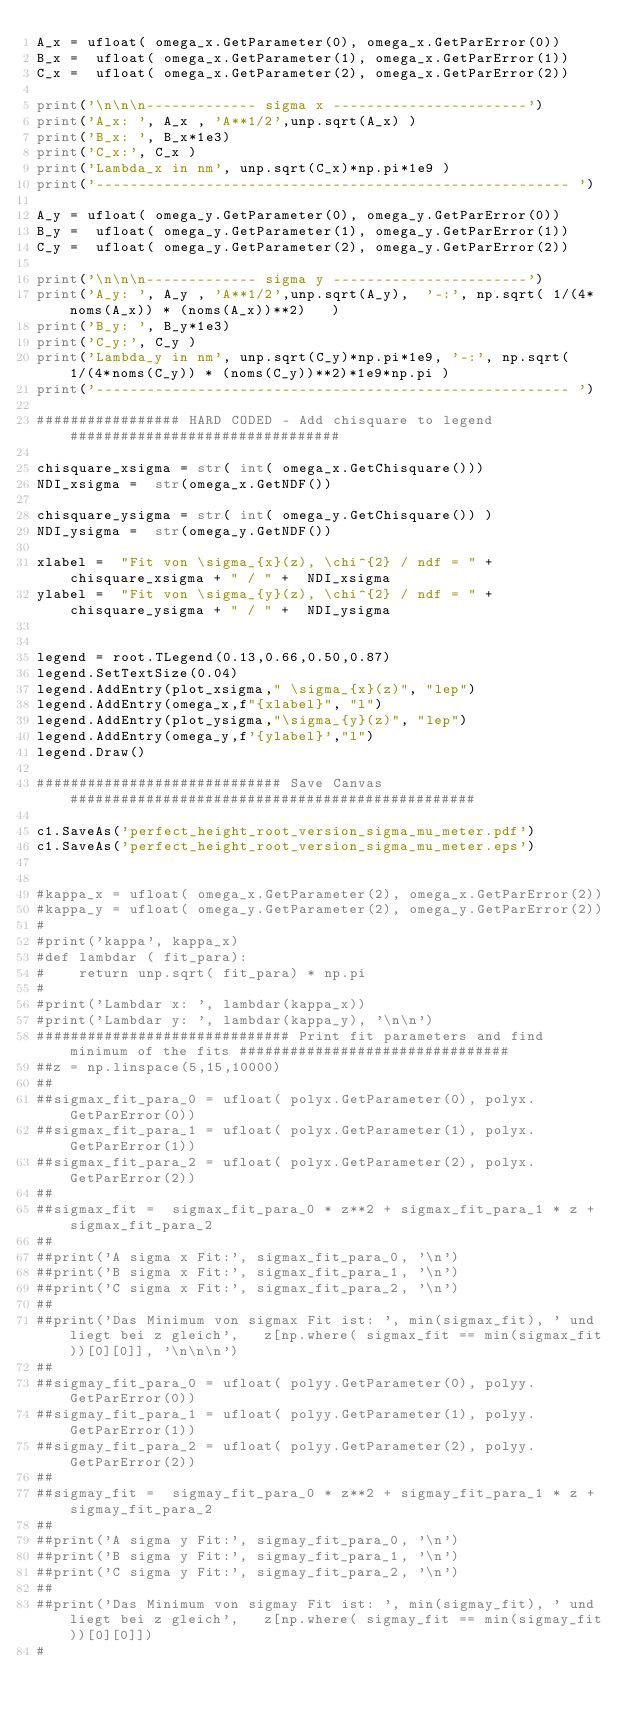<code> <loc_0><loc_0><loc_500><loc_500><_Python_>A_x = ufloat( omega_x.GetParameter(0), omega_x.GetParError(0))
B_x =  ufloat( omega_x.GetParameter(1), omega_x.GetParError(1))
C_x =  ufloat( omega_x.GetParameter(2), omega_x.GetParError(2))

print('\n\n\n------------- sigma x -----------------------')
print('A_x: ', A_x , 'A**1/2',unp.sqrt(A_x) )
print('B_x: ', B_x*1e3)
print('C_x:', C_x )
print('Lambda_x in nm', unp.sqrt(C_x)*np.pi*1e9 )
print('-------------------------------------------------------- ')

A_y = ufloat( omega_y.GetParameter(0), omega_y.GetParError(0))
B_y =  ufloat( omega_y.GetParameter(1), omega_y.GetParError(1))
C_y =  ufloat( omega_y.GetParameter(2), omega_y.GetParError(2))

print('\n\n\n------------- sigma y -----------------------')
print('A_y: ', A_y , 'A**1/2',unp.sqrt(A_y),  '-:', np.sqrt( 1/(4*noms(A_x)) * (noms(A_x))**2)   )
print('B_y: ', B_y*1e3)
print('C_y:', C_y )
print('Lambda_y in nm', unp.sqrt(C_y)*np.pi*1e9, '-:', np.sqrt( 1/(4*noms(C_y)) * (noms(C_y))**2)*1e9*np.pi )
print('-------------------------------------------------------- ')

################# HARD CODED - Add chisquare to legend ################################

chisquare_xsigma = str( int( omega_x.GetChisquare()))
NDI_xsigma =  str(omega_x.GetNDF())

chisquare_ysigma = str( int( omega_y.GetChisquare()) )
NDI_ysigma =  str(omega_y.GetNDF())

xlabel =  "Fit von \sigma_{x}(z), \chi^{2} / ndf = " + chisquare_xsigma + " / " +  NDI_xsigma
ylabel =  "Fit von \sigma_{y}(z), \chi^{2} / ndf = " + chisquare_ysigma + " / " +  NDI_ysigma


legend = root.TLegend(0.13,0.66,0.50,0.87)
legend.SetTextSize(0.04)
legend.AddEntry(plot_xsigma," \sigma_{x}(z)", "lep")
legend.AddEntry(omega_x,f"{xlabel}", "l")
legend.AddEntry(plot_ysigma,"\sigma_{y}(z)", "lep")
legend.AddEntry(omega_y,f'{ylabel}',"l")
legend.Draw()

############################# Save Canvas ################################################

c1.SaveAs('perfect_height_root_version_sigma_mu_meter.pdf')
c1.SaveAs('perfect_height_root_version_sigma_mu_meter.eps')


#kappa_x = ufloat( omega_x.GetParameter(2), omega_x.GetParError(2))
#kappa_y = ufloat( omega_y.GetParameter(2), omega_y.GetParError(2))
#
#print('kappa', kappa_x)
#def lambdar ( fit_para):
#    return unp.sqrt( fit_para) * np.pi
#
#print('Lambdar x: ', lambdar(kappa_x))
#print('Lambdar y: ', lambdar(kappa_y), '\n\n')
############################## Print fit parameters and find minimum of the fits ################################
##z = np.linspace(5,15,10000)
##
##sigmax_fit_para_0 = ufloat( polyx.GetParameter(0), polyx.GetParError(0))
##sigmax_fit_para_1 = ufloat( polyx.GetParameter(1), polyx.GetParError(1))
##sigmax_fit_para_2 = ufloat( polyx.GetParameter(2), polyx.GetParError(2))
##
##sigmax_fit =  sigmax_fit_para_0 * z**2 + sigmax_fit_para_1 * z + sigmax_fit_para_2
##
##print('A sigma x Fit:', sigmax_fit_para_0, '\n')
##print('B sigma x Fit:', sigmax_fit_para_1, '\n')
##print('C sigma x Fit:', sigmax_fit_para_2, '\n')
##
##print('Das Minimum von sigmax Fit ist: ', min(sigmax_fit), ' und liegt bei z gleich',   z[np.where( sigmax_fit == min(sigmax_fit))[0][0]], '\n\n\n')
##
##sigmay_fit_para_0 = ufloat( polyy.GetParameter(0), polyy.GetParError(0))
##sigmay_fit_para_1 = ufloat( polyy.GetParameter(1), polyy.GetParError(1))
##sigmay_fit_para_2 = ufloat( polyy.GetParameter(2), polyy.GetParError(2))
##
##sigmay_fit =  sigmay_fit_para_0 * z**2 + sigmay_fit_para_1 * z + sigmay_fit_para_2
##
##print('A sigma y Fit:', sigmay_fit_para_0, '\n')
##print('B sigma y Fit:', sigmay_fit_para_1, '\n')
##print('C sigma y Fit:', sigmay_fit_para_2, '\n')
##
##print('Das Minimum von sigmay Fit ist: ', min(sigmay_fit), ' und liegt bei z gleich',   z[np.where( sigmay_fit == min(sigmay_fit))[0][0]])
#
</code> 